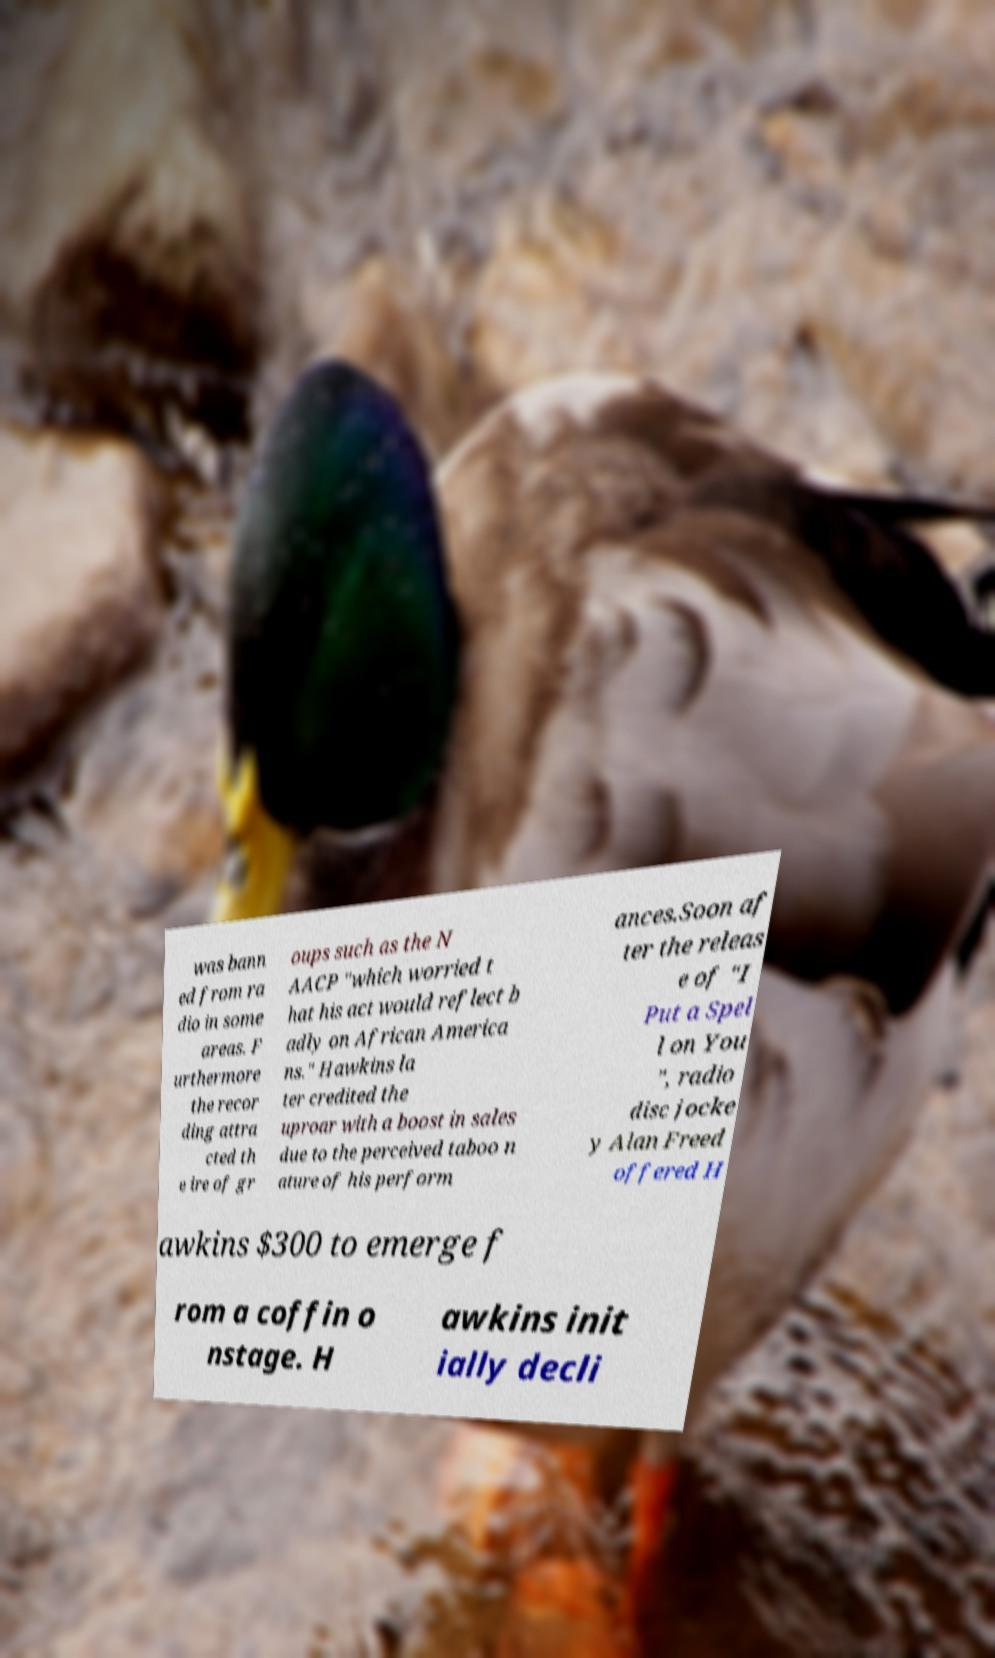Please read and relay the text visible in this image. What does it say? was bann ed from ra dio in some areas. F urthermore the recor ding attra cted th e ire of gr oups such as the N AACP "which worried t hat his act would reflect b adly on African America ns." Hawkins la ter credited the uproar with a boost in sales due to the perceived taboo n ature of his perform ances.Soon af ter the releas e of "I Put a Spel l on You ", radio disc jocke y Alan Freed offered H awkins $300 to emerge f rom a coffin o nstage. H awkins init ially decli 